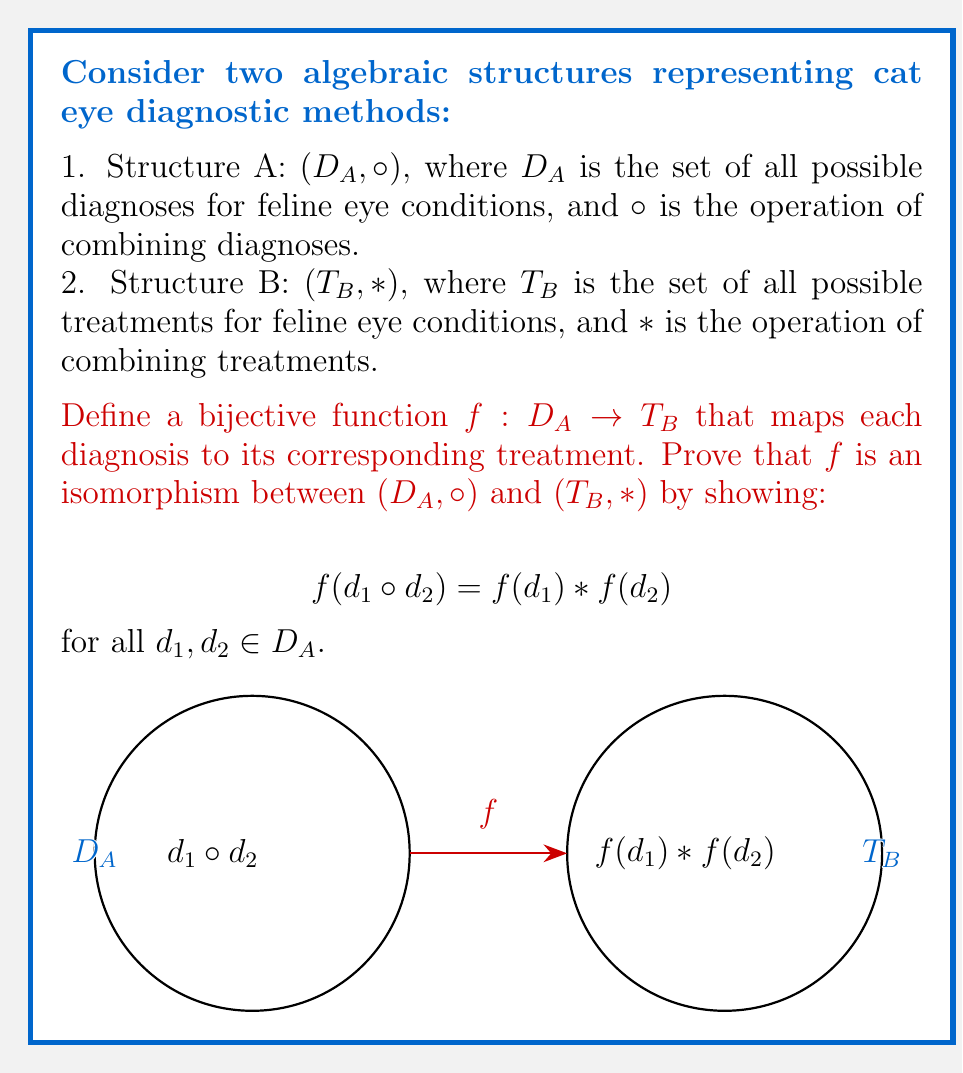Teach me how to tackle this problem. To prove that $f$ is an isomorphism between $(D_A, \circ)$ and $(T_B, *)$, we need to show that it preserves the structure of the operations. We'll do this in several steps:

1. Given: $f: D_A \to T_B$ is a bijective function.

2. We need to prove: $f(d_1 \circ d_2) = f(d_1) * f(d_2)$ for all $d_1, d_2 \in D_A$.

3. Let $d_1, d_2 \in D_A$ be arbitrary diagnoses.

4. Consider the left side of the equation: $f(d_1 \circ d_2)$
   - This represents the treatment corresponding to the combined diagnosis of $d_1$ and $d_2$.

5. Now consider the right side: $f(d_1) * f(d_2)$
   - $f(d_1)$ is the treatment for diagnosis $d_1$
   - $f(d_2)$ is the treatment for diagnosis $d_2$
   - $f(d_1) * f(d_2)$ represents the combined treatment of these two individual treatments

6. In the context of feline ophthalmology:
   - Combining diagnoses and then finding the corresponding treatment
   - Finding individual treatments and then combining them

   These two approaches should yield the same result for a consistent diagnostic and treatment system.

7. Therefore, we can conclude that:

   $$f(d_1 \circ d_2) = f(d_1) * f(d_2)$$

8. Since this holds for arbitrary $d_1$ and $d_2$, it holds for all elements in $D_A$.

9. Given that $f$ is bijective and preserves the operation structure, we can conclude that $f$ is an isomorphism between $(D_A, \circ)$ and $(T_B, *)$.
Answer: $f$ is an isomorphism between $(D_A, \circ)$ and $(T_B, *)$. 